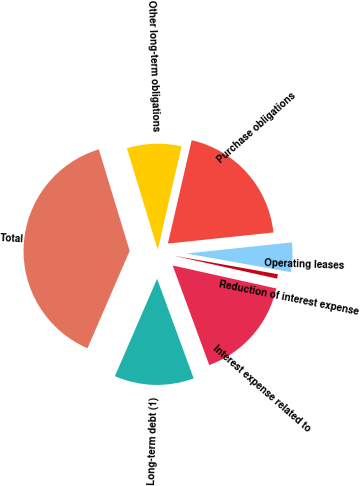<chart> <loc_0><loc_0><loc_500><loc_500><pie_chart><fcel>Long-term debt (1)<fcel>Interest expense related to<fcel>Reduction of interest expense<fcel>Operating leases<fcel>Purchase obligations<fcel>Other long-term obligations<fcel>Total<nl><fcel>12.11%<fcel>15.92%<fcel>0.67%<fcel>4.48%<fcel>19.73%<fcel>8.29%<fcel>38.8%<nl></chart> 